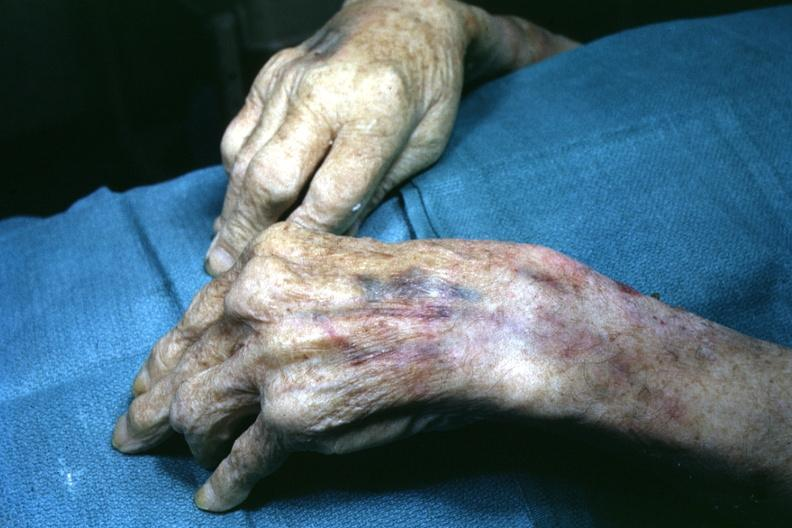re extremities present?
Answer the question using a single word or phrase. Yes 